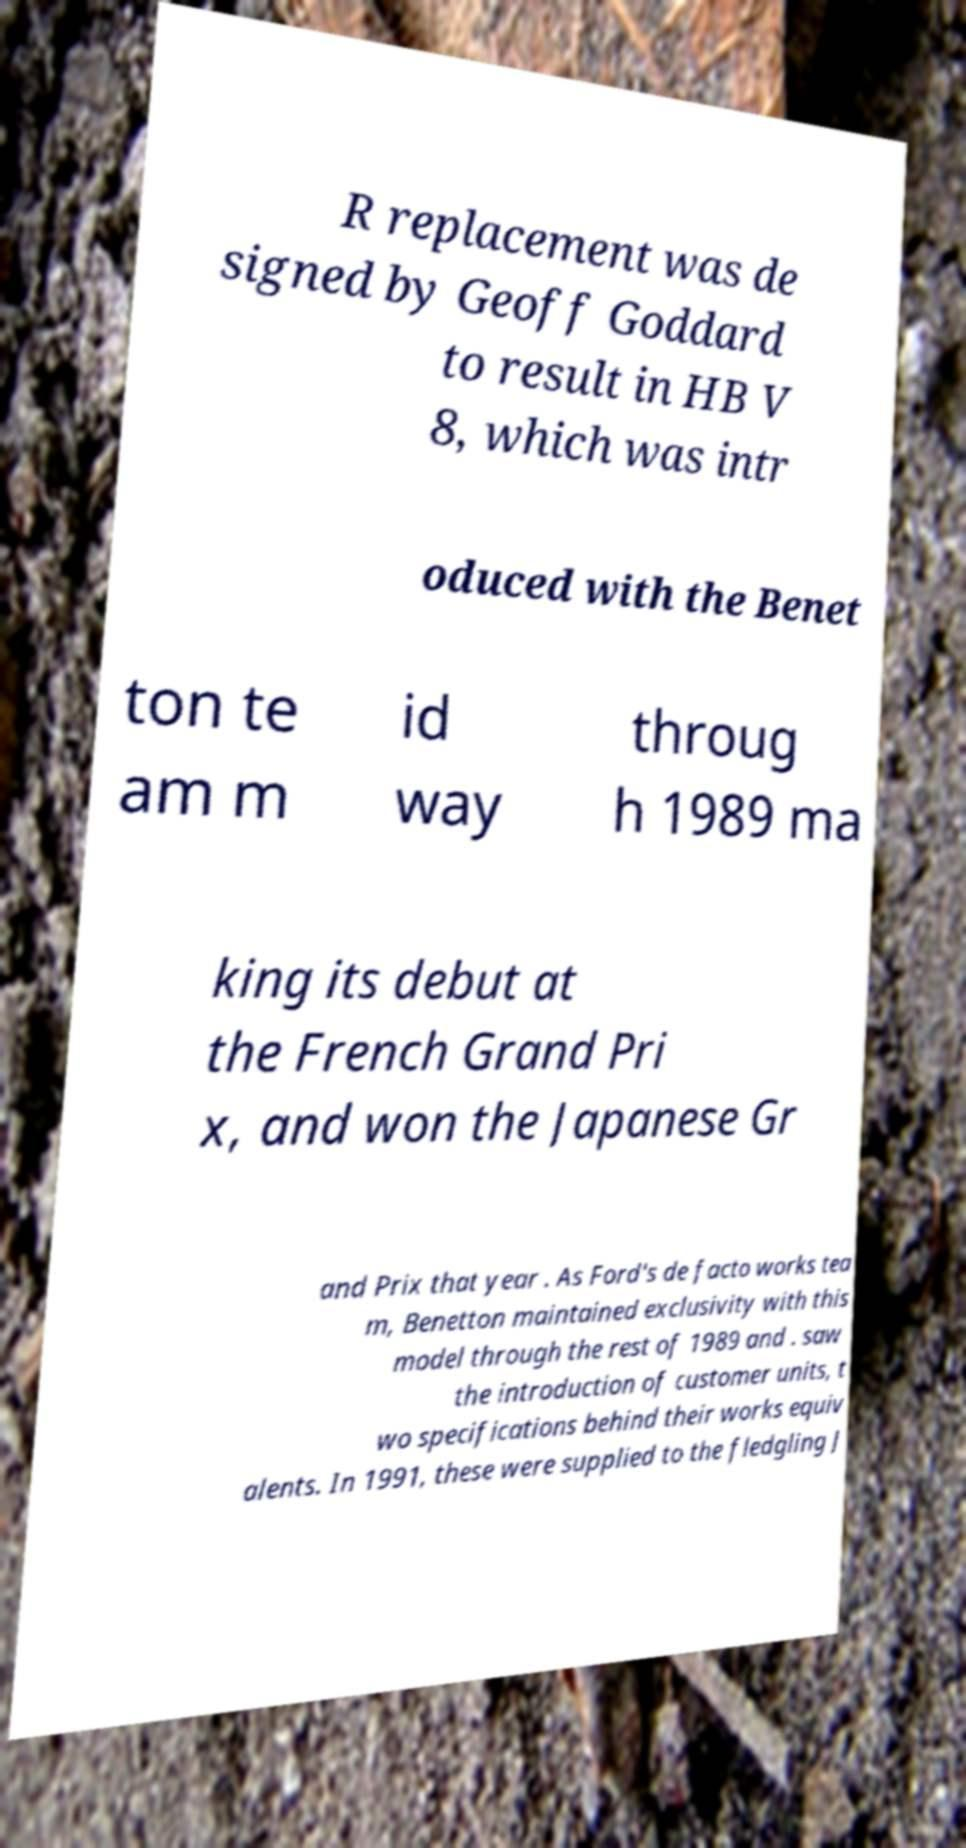What messages or text are displayed in this image? I need them in a readable, typed format. R replacement was de signed by Geoff Goddard to result in HB V 8, which was intr oduced with the Benet ton te am m id way throug h 1989 ma king its debut at the French Grand Pri x, and won the Japanese Gr and Prix that year . As Ford's de facto works tea m, Benetton maintained exclusivity with this model through the rest of 1989 and . saw the introduction of customer units, t wo specifications behind their works equiv alents. In 1991, these were supplied to the fledgling J 